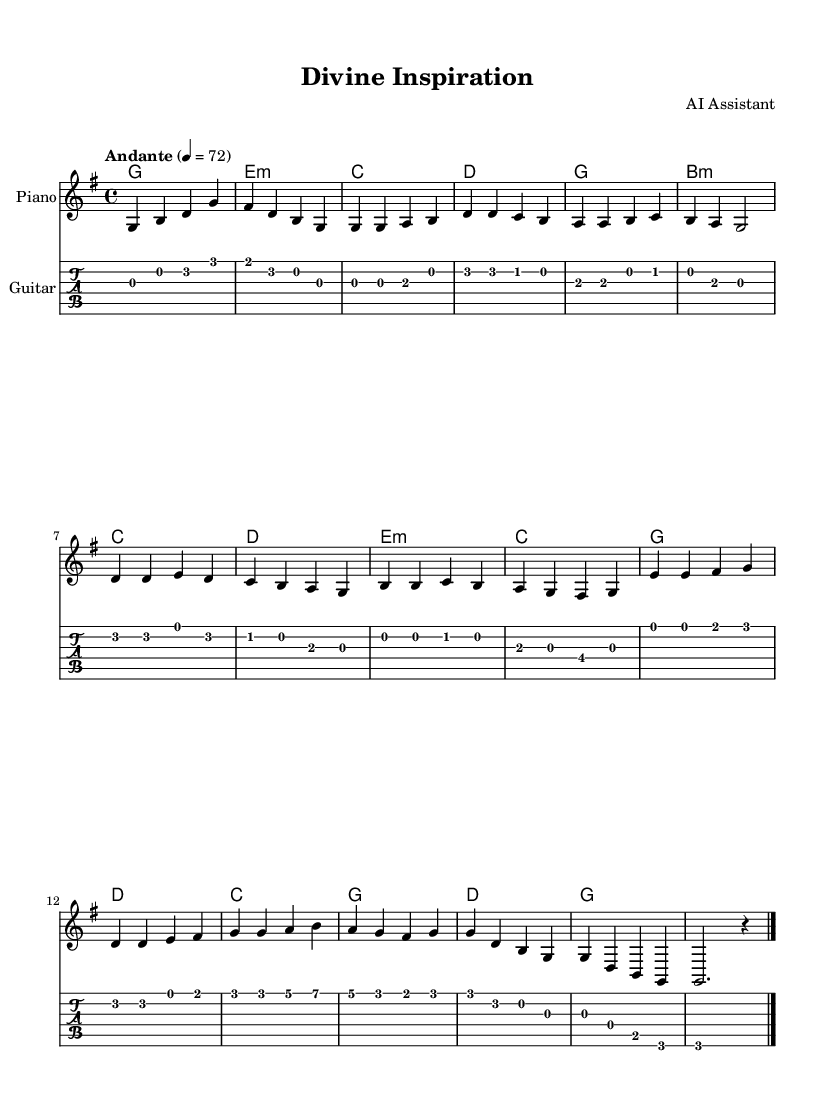What is the key signature of this music? The key signature is indicated by the sharp (fis) which shows that the piece is in G major with one sharp.
Answer: G major What is the time signature of this piece? The time signature is shown at the beginning of the score as 4/4, indicating four beats per measure.
Answer: 4/4 What is the tempo marking of this music? The tempo marking at the start indicates "Andante" at a speed of quarter note equals 72 beats per minute.
Answer: Andante 4 = 72 How many sections are there in this composition? By analyzing the structure, there are five distinct sections: Intro, Verse, Chorus, Bridge, and Outro.
Answer: Five What type of music is this score based on its title and structure? The title "Divine Inspiration" and the structured sections suggest it is appropriate for religious worship or spiritual focus.
Answer: Religious worship What instrument is specified for the primary melody? The score contains a staff for piano, indicating it is the primary instrument for carrying the melody.
Answer: Piano What chords are used in the harmonies section? The harmonies show a progression that consists of G, E minor, C, and D, suggesting a typical progression found in religious music.
Answer: G, E minor, C, D 